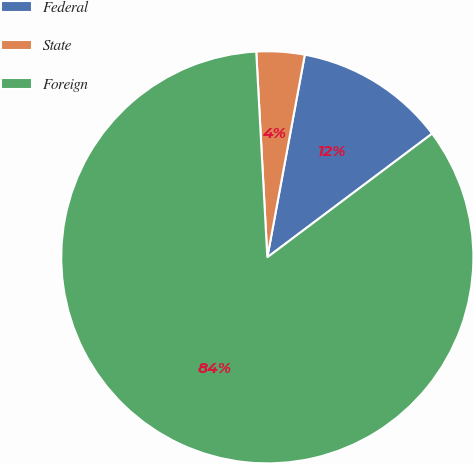<chart> <loc_0><loc_0><loc_500><loc_500><pie_chart><fcel>Federal<fcel>State<fcel>Foreign<nl><fcel>11.84%<fcel>3.77%<fcel>84.39%<nl></chart> 